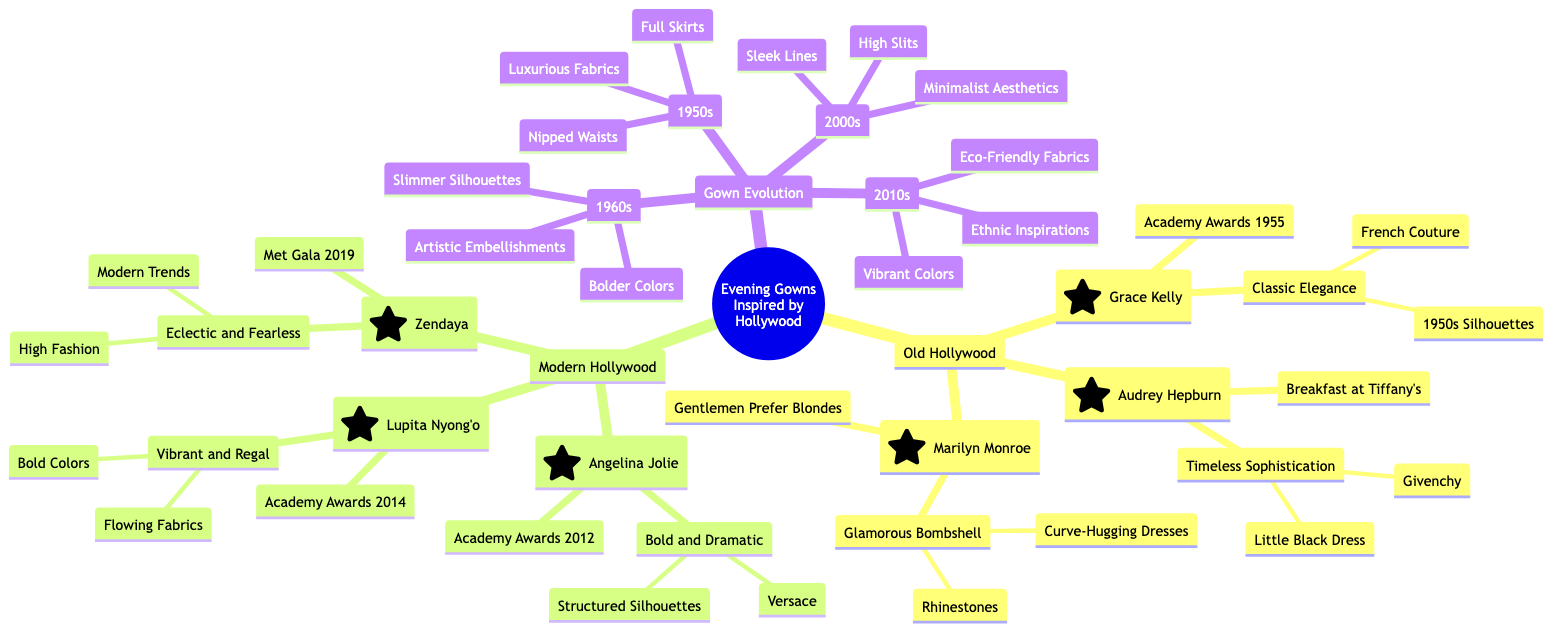What is the iconic gown worn by Grace Kelly? The diagram shows that Grace Kelly's iconic gown is "Academy Awards 1955." Therefore, the answer is directly retrieved from Grace Kelly's node.
Answer: Academy Awards 1955 Which actress is known for the "Timeless Sophistication" look? By examining the actress nodes, we find that Audrey Hepburn is associated with the "Timeless Sophistication" signature look. This information is directly stated in her section.
Answer: Audrey Hepburn What decade is characterized by "Vibrant Colors" and "Ethnic Inspirations"? The diagram lists the 2010s under Gown Evolution that includes these characteristics, so we can match them to the correct decade by locating the relevant description.
Answer: 2010s How many actresses are listed under Old Hollywood? By counting the nodes under the Old Hollywood category in the diagram, we find there are three actresses: Grace Kelly, Audrey Hepburn, and Marilyn Monroe. This requires simple counting of nodes.
Answer: 3 Which actress inspired the “Minimalist Aesthetics” in the 2000s? Looking at the 2000s section in Gown Evolution, it reveals that Angelina Jolie is the actress associated with this characteristic. This can be answered by inspecting the connections between the characteristics and influential actresses.
Answer: Angelina Jolie What signature look is associated with Lupita Nyong'o? The diagram specifies that Lupita Nyong'o has the signature look of "Vibrant and Regal". This information is directly provided in her profile.
Answer: Vibrant and Regal Which actress influenced the fashion in the 1960s with "Bolder Colors"? The 1960s section of Gown Evolution mentions that Marilyn Monroe is an influential actress during that decade associated with "Bolder Colors." This links the actress to the specific decade and characteristics.
Answer: Marilyn Monroe What type of silhouettes did Angelina Jolie's influential gowns have? In the section for Angelina Jolie, it is mentioned that her signature look features "Structured Silhouettes." This connects the actress to specific characteristics of her gown style.
Answer: Structured Silhouettes What is the defining characteristic of gowns from the 1950s? The 1950s node lists "Full Skirts," "Nipped Waists," and "Luxurious Fabrics" as defining characteristics. Therefore, any of these can be used as the answer.
Answer: Full Skirts 